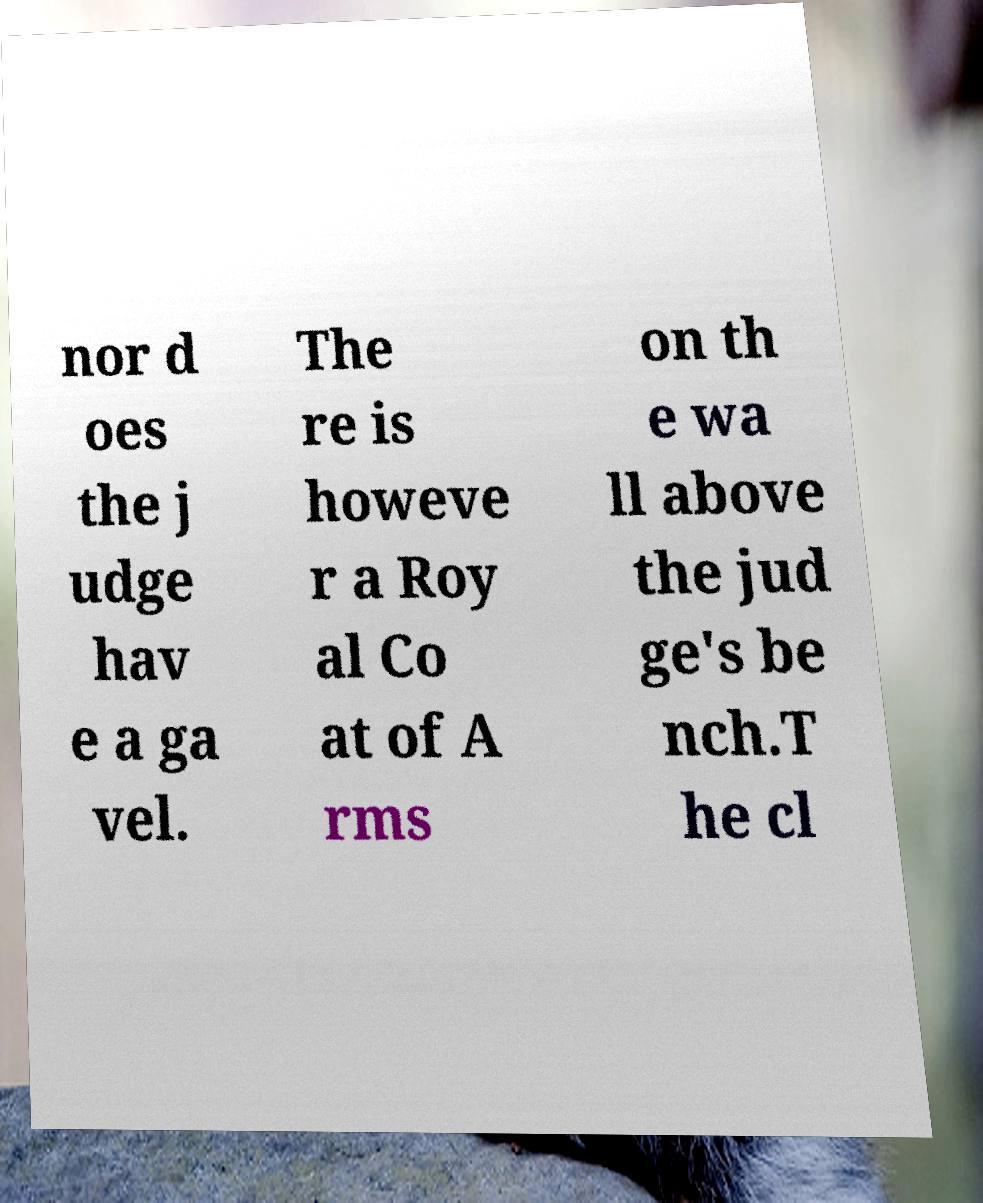I need the written content from this picture converted into text. Can you do that? nor d oes the j udge hav e a ga vel. The re is howeve r a Roy al Co at of A rms on th e wa ll above the jud ge's be nch.T he cl 